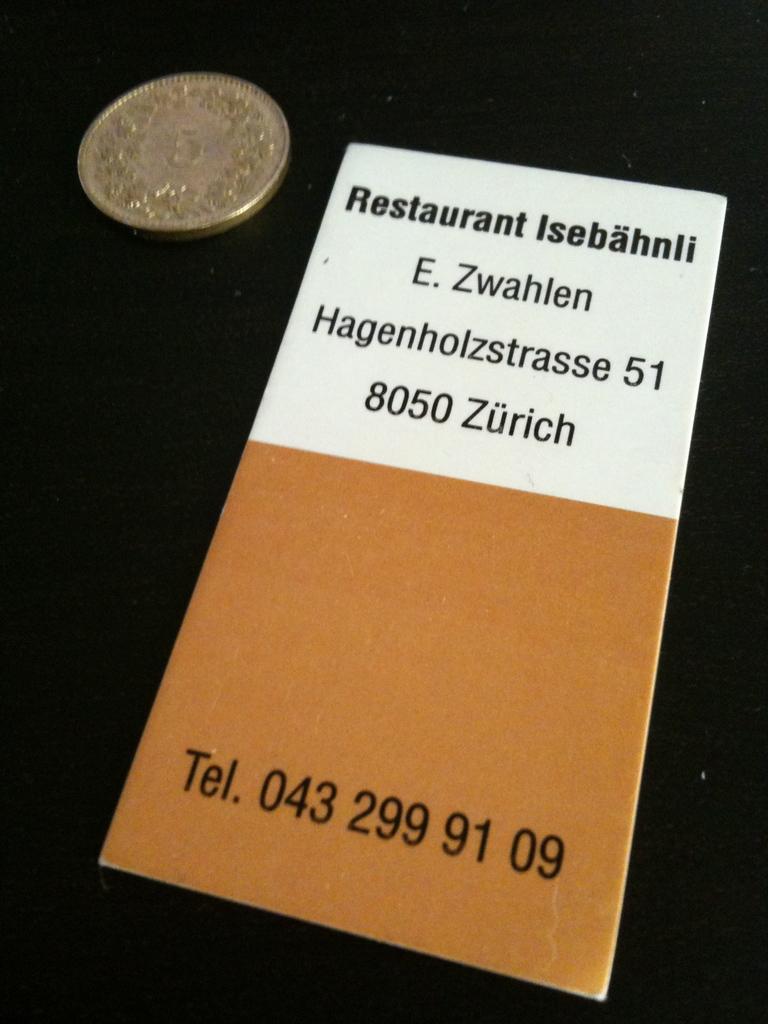What is the phone number of the restaurant?
Your answer should be very brief. 043 299 91 09. What is the postal code for zurich?
Your answer should be compact. 8050. 